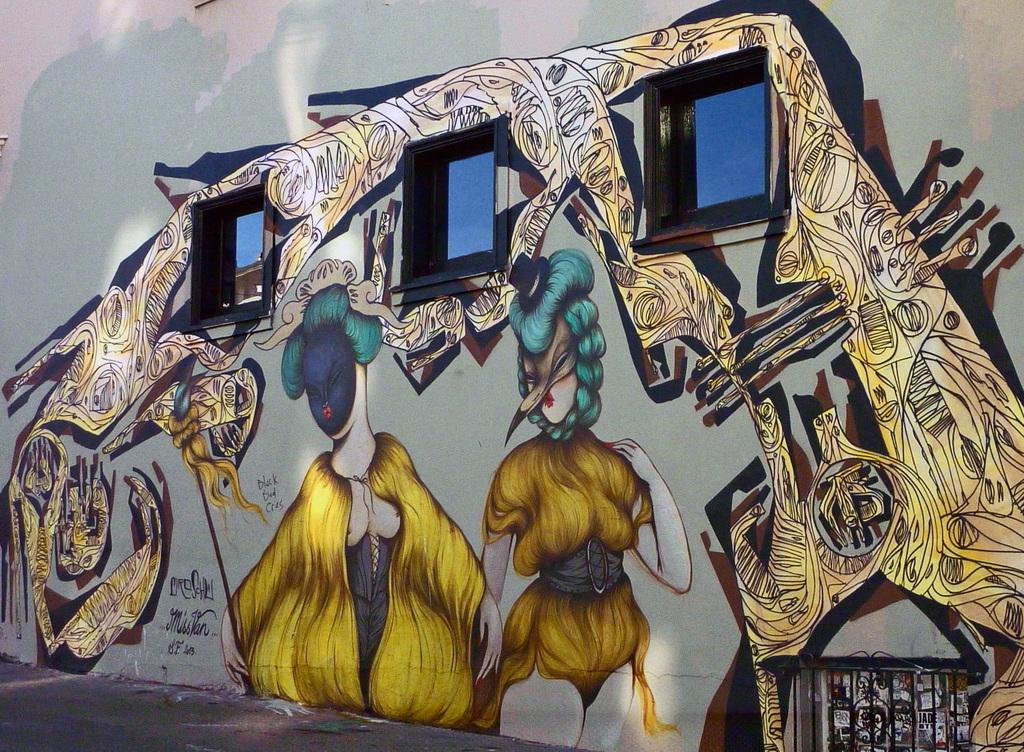What type of artwork can be seen in the image? There are wall paintings in the image. Where are the wall paintings located? The wall paintings are on a wall in the image. What other architectural features can be seen in the image? There are windows and a door in the image. What can be inferred about the time of day when the image was taken? The image was likely taken during the day, as there is sufficient light to see the wall paintings, windows, and door. What type of writing can be seen on the wall paintings in the image? There is no writing visible on the wall paintings in the image. Is there any coal present in the image? There is no coal present in the image. 